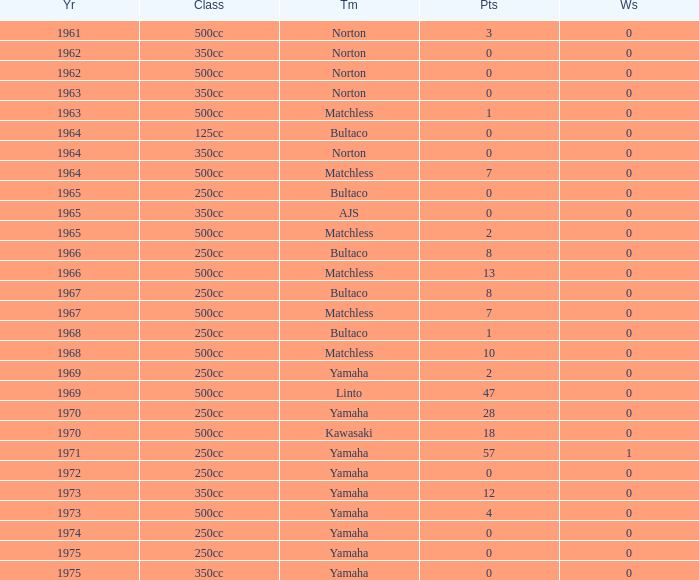What is the sum of all points in 1975 with 0 wins? None. 